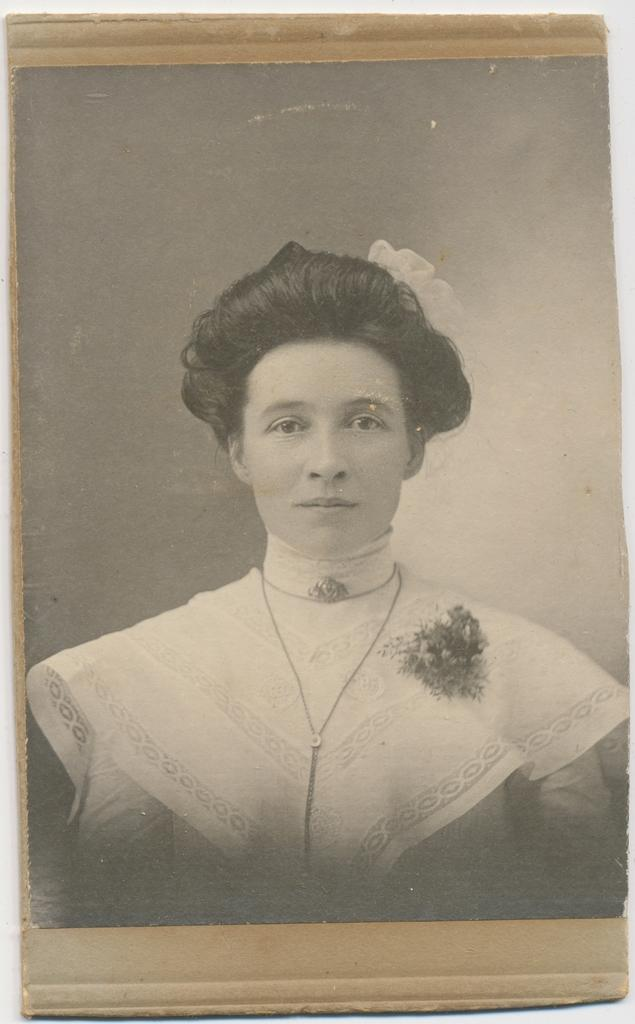What object is present in the image that typically holds a photograph? There is a photo frame in the image. What can be seen inside the photo frame? The photo frame contains an image of a woman. What type of health advice is the woman in the photo frame giving in the image? There is no indication in the image that the woman in the photo frame is giving any health advice. 